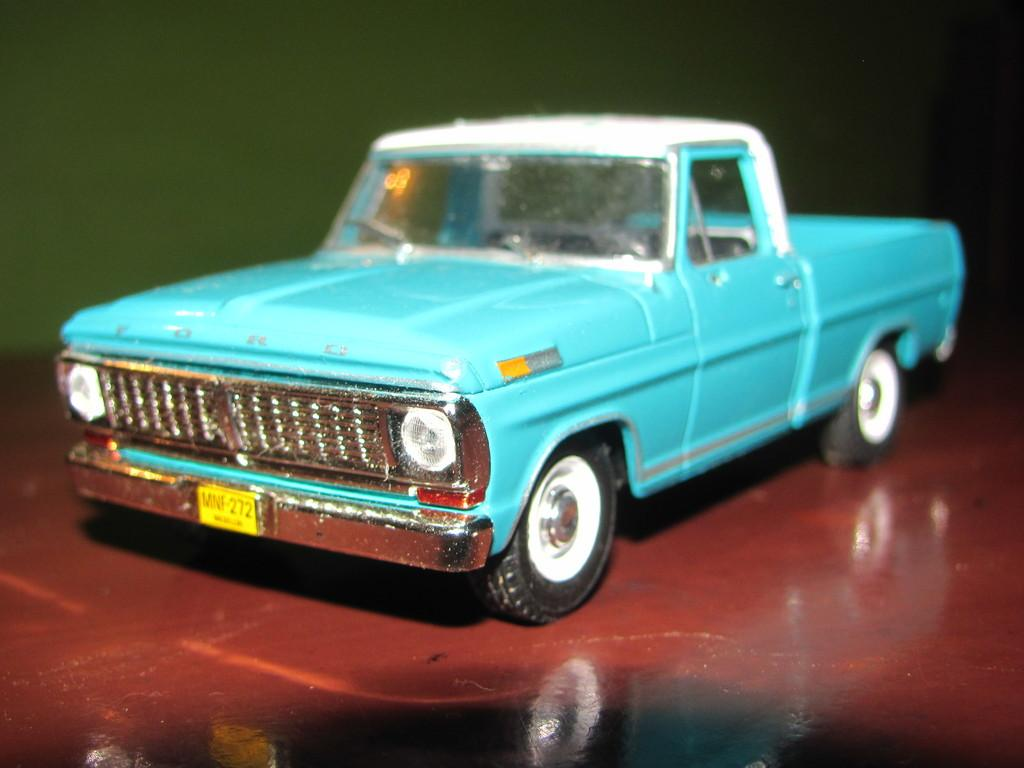What type of toy is present in the image? There is a small blue color toy car in the image. What is the color of the toy car? The toy car is blue. What is the color of the floor in the image? The floor in the image is red. How does the toy car push the other toys in the image? There are no other toys present in the image for the toy car to push. Can you tell me how many times the toy car jumps in the image? The toy car does not jump in the image; it is stationary on the red floor. 